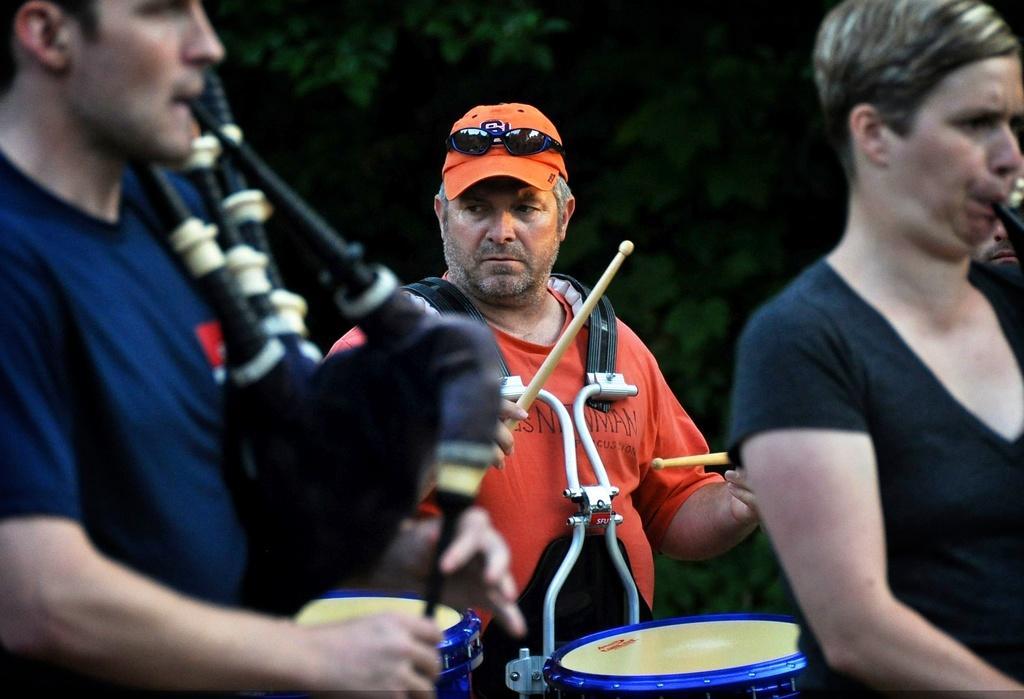Please provide a concise description of this image. In this picture there are three persons playing musical instruments. A man in the center wearing orange t shirt and a orange cap, he is playing a drums. Towards the left corner there is a man wearing a blue t shirt and playing a trumpet. Towards the left there is a person playing a musical instrument. In the background there are group of trees. 